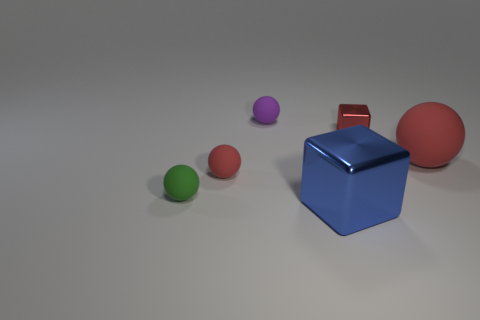The thing that is made of the same material as the red block is what color?
Offer a very short reply. Blue. Is there a red thing right of the small ball on the right side of the small red sphere?
Your response must be concise. Yes. What is the color of the shiny cube that is the same size as the green ball?
Offer a terse response. Red. How many things are red metal objects or tiny green shiny cylinders?
Your response must be concise. 1. What size is the shiny object behind the red rubber ball on the left side of the rubber sphere to the right of the big shiny cube?
Provide a succinct answer. Small. How many objects are the same color as the large metal block?
Keep it short and to the point. 0. What number of big red balls have the same material as the blue thing?
Provide a succinct answer. 0. How many things are either large brown metallic things or red spheres that are to the left of the red cube?
Provide a short and direct response. 1. What color is the tiny matte thing that is to the left of the red rubber ball on the left side of the red sphere that is to the right of the purple matte object?
Provide a succinct answer. Green. There is a block that is in front of the tiny shiny cube; what size is it?
Provide a succinct answer. Large. 